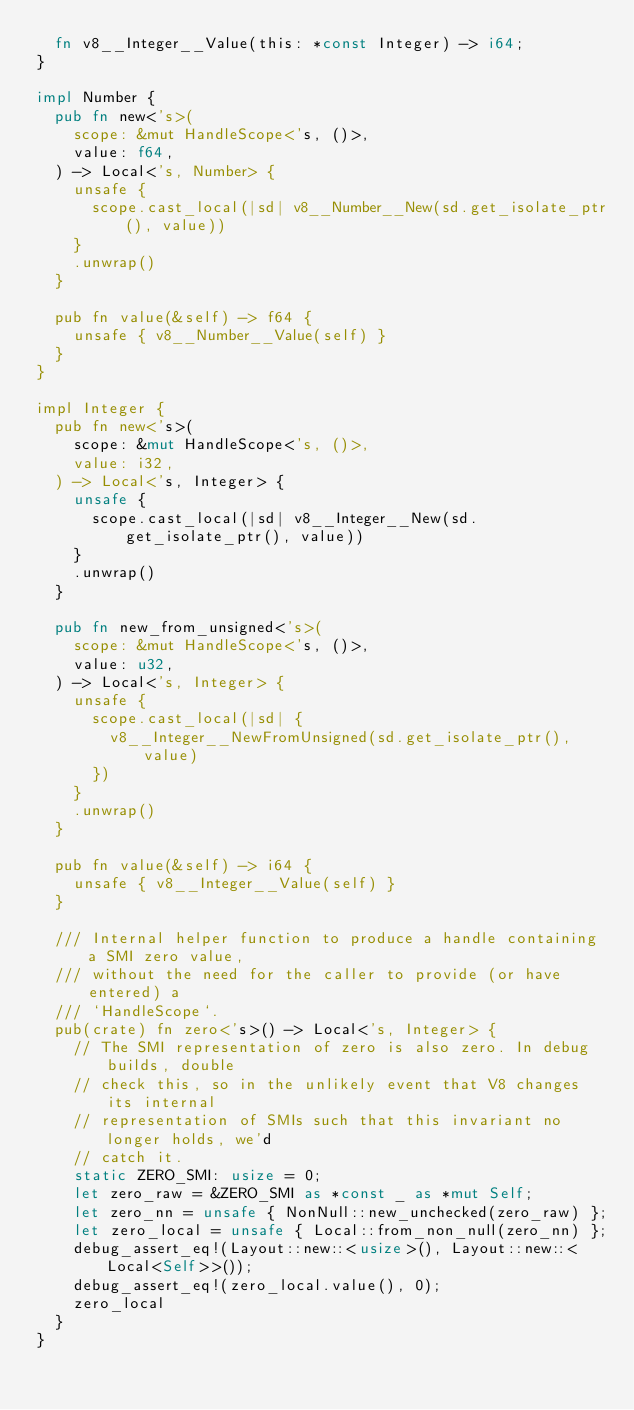Convert code to text. <code><loc_0><loc_0><loc_500><loc_500><_Rust_>  fn v8__Integer__Value(this: *const Integer) -> i64;
}

impl Number {
  pub fn new<'s>(
    scope: &mut HandleScope<'s, ()>,
    value: f64,
  ) -> Local<'s, Number> {
    unsafe {
      scope.cast_local(|sd| v8__Number__New(sd.get_isolate_ptr(), value))
    }
    .unwrap()
  }

  pub fn value(&self) -> f64 {
    unsafe { v8__Number__Value(self) }
  }
}

impl Integer {
  pub fn new<'s>(
    scope: &mut HandleScope<'s, ()>,
    value: i32,
  ) -> Local<'s, Integer> {
    unsafe {
      scope.cast_local(|sd| v8__Integer__New(sd.get_isolate_ptr(), value))
    }
    .unwrap()
  }

  pub fn new_from_unsigned<'s>(
    scope: &mut HandleScope<'s, ()>,
    value: u32,
  ) -> Local<'s, Integer> {
    unsafe {
      scope.cast_local(|sd| {
        v8__Integer__NewFromUnsigned(sd.get_isolate_ptr(), value)
      })
    }
    .unwrap()
  }

  pub fn value(&self) -> i64 {
    unsafe { v8__Integer__Value(self) }
  }

  /// Internal helper function to produce a handle containing a SMI zero value,
  /// without the need for the caller to provide (or have entered) a
  /// `HandleScope`.
  pub(crate) fn zero<'s>() -> Local<'s, Integer> {
    // The SMI representation of zero is also zero. In debug builds, double
    // check this, so in the unlikely event that V8 changes its internal
    // representation of SMIs such that this invariant no longer holds, we'd
    // catch it.
    static ZERO_SMI: usize = 0;
    let zero_raw = &ZERO_SMI as *const _ as *mut Self;
    let zero_nn = unsafe { NonNull::new_unchecked(zero_raw) };
    let zero_local = unsafe { Local::from_non_null(zero_nn) };
    debug_assert_eq!(Layout::new::<usize>(), Layout::new::<Local<Self>>());
    debug_assert_eq!(zero_local.value(), 0);
    zero_local
  }
}
</code> 